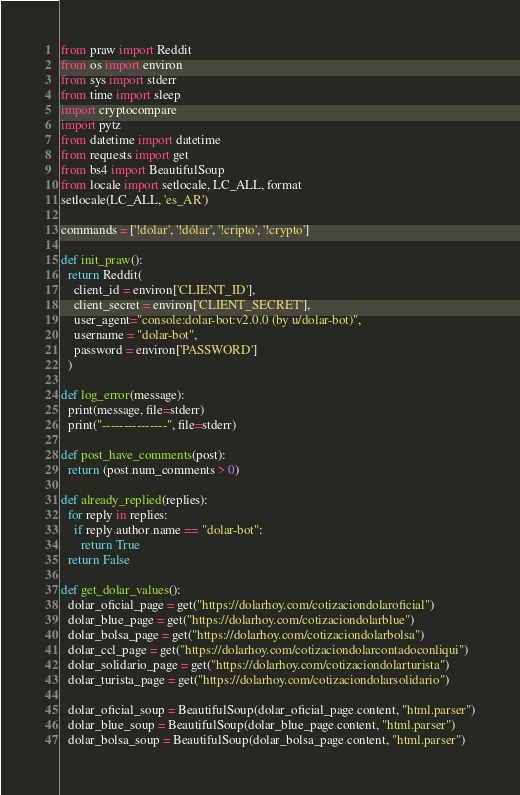<code> <loc_0><loc_0><loc_500><loc_500><_Python_>from praw import Reddit
from os import environ
from sys import stderr
from time import sleep
import cryptocompare
import pytz
from datetime import datetime
from requests import get
from bs4 import BeautifulSoup
from locale import setlocale, LC_ALL, format
setlocale(LC_ALL, 'es_AR')

commands = ['!dolar', '!dólar', '!cripto', '!crypto']

def init_praw():
  return Reddit(
    client_id = environ['CLIENT_ID'],
    client_secret = environ['CLIENT_SECRET'],
    user_agent="console:dolar-bot:v2.0.0 (by u/dolar-bot)",
    username = "dolar-bot",
    password = environ['PASSWORD']
  )

def log_error(message):
  print(message, file=stderr)
  print("---------------", file=stderr)

def post_have_comments(post):
  return (post.num_comments > 0)

def already_replied(replies):
  for reply in replies:
    if reply.author.name == "dolar-bot":
      return True
  return False

def get_dolar_values():
  dolar_oficial_page = get("https://dolarhoy.com/cotizaciondolaroficial")
  dolar_blue_page = get("https://dolarhoy.com/cotizaciondolarblue")
  dolar_bolsa_page = get("https://dolarhoy.com/cotizaciondolarbolsa")
  dolar_ccl_page = get("https://dolarhoy.com/cotizaciondolarcontadoconliqui")
  dolar_solidario_page = get("https://dolarhoy.com/cotizaciondolarturista")
  dolar_turista_page = get("https://dolarhoy.com/cotizaciondolarsolidario")

  dolar_oficial_soup = BeautifulSoup(dolar_oficial_page.content, "html.parser")
  dolar_blue_soup = BeautifulSoup(dolar_blue_page.content, "html.parser")
  dolar_bolsa_soup = BeautifulSoup(dolar_bolsa_page.content, "html.parser")</code> 